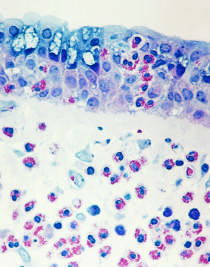what is the late-phase reaction characterized by?
Answer the question using a single word or phrase. An inflammatory infiltrate rich in eosinophils 